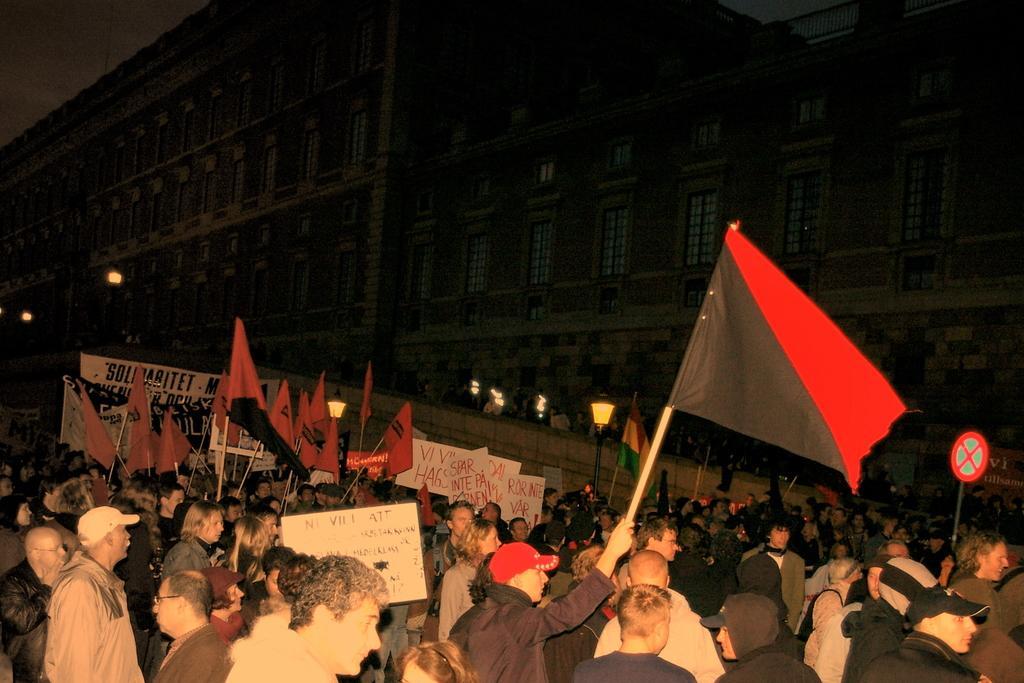Describe this image in one or two sentences. In this image, we can see a crowd. There are some persons holding flags with their hands. There is a sign board in the bottom right of the image. There is a building in the middle of the image. 